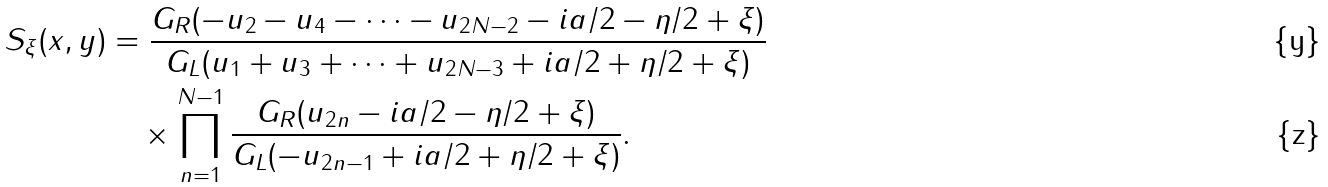Convert formula to latex. <formula><loc_0><loc_0><loc_500><loc_500>S _ { \xi } ( x , y ) & = \frac { G _ { R } ( - u _ { 2 } - u _ { 4 } - \cdots - u _ { 2 N - 2 } - i a / 2 - \eta / 2 + \xi ) } { G _ { L } ( u _ { 1 } + u _ { 3 } + \cdots + u _ { 2 N - 3 } + i a / 2 + \eta / 2 + \xi ) } \\ & \quad \times \prod _ { n = 1 } ^ { N - 1 } \frac { G _ { R } ( u _ { 2 n } - i a / 2 - \eta / 2 + \xi ) } { G _ { L } ( - u _ { 2 n - 1 } + i a / 2 + \eta / 2 + \xi ) } .</formula> 